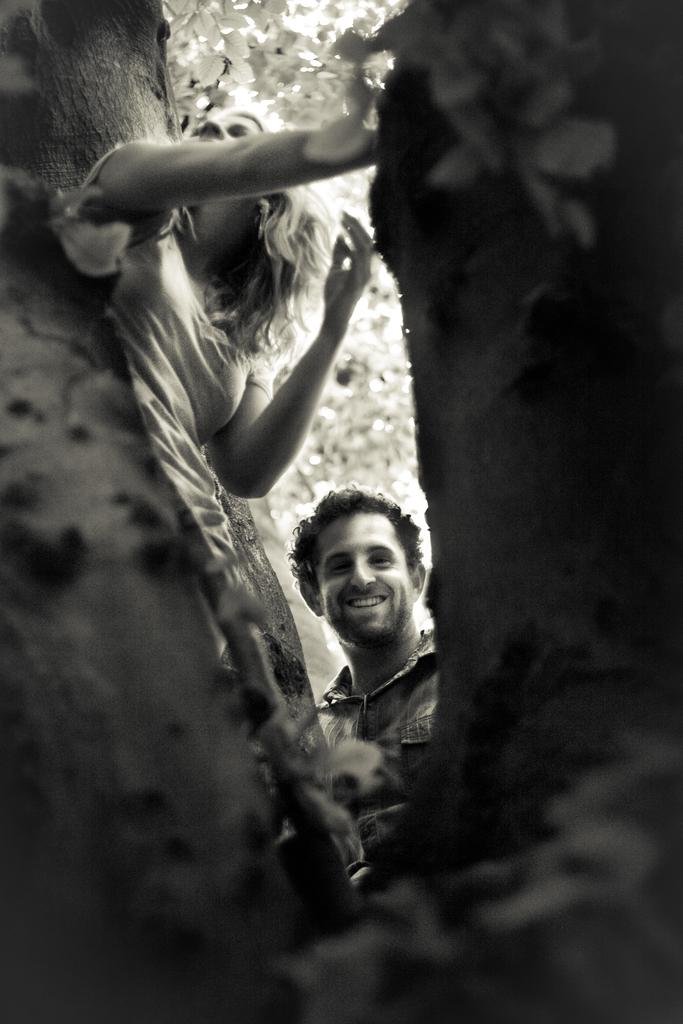How many people are in the image? There are two persons in the image. What are the two persons doing in the image? The two persons are standing in a log. What type of roof can be seen on the log in the image? There is no roof present in the image, as it features two persons standing in a log. 